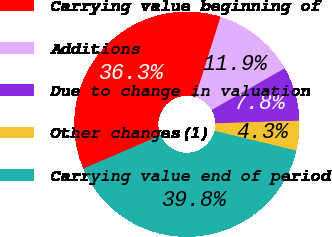Convert chart to OTSL. <chart><loc_0><loc_0><loc_500><loc_500><pie_chart><fcel>Carrying value beginning of<fcel>Additions<fcel>Due to change in valuation<fcel>Other changes(1)<fcel>Carrying value end of period<nl><fcel>36.29%<fcel>11.9%<fcel>7.76%<fcel>4.26%<fcel>39.79%<nl></chart> 